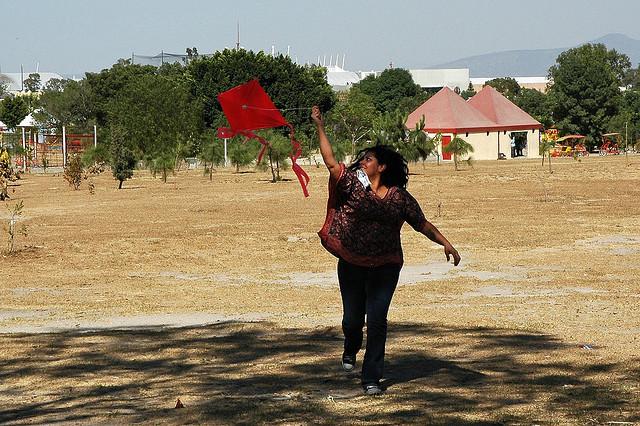What is the woman standing on?
Concise answer only. Dirt. What kind of shoes is she wearing?
Keep it brief. Sneakers. What is in the far distance?
Write a very short answer. House. Yes, it is flying?
Keep it brief. Yes. What game is this?
Answer briefly. Kiting. What is the person standing in?
Keep it brief. Field. Is the kite flying?
Short answer required. Yes. 